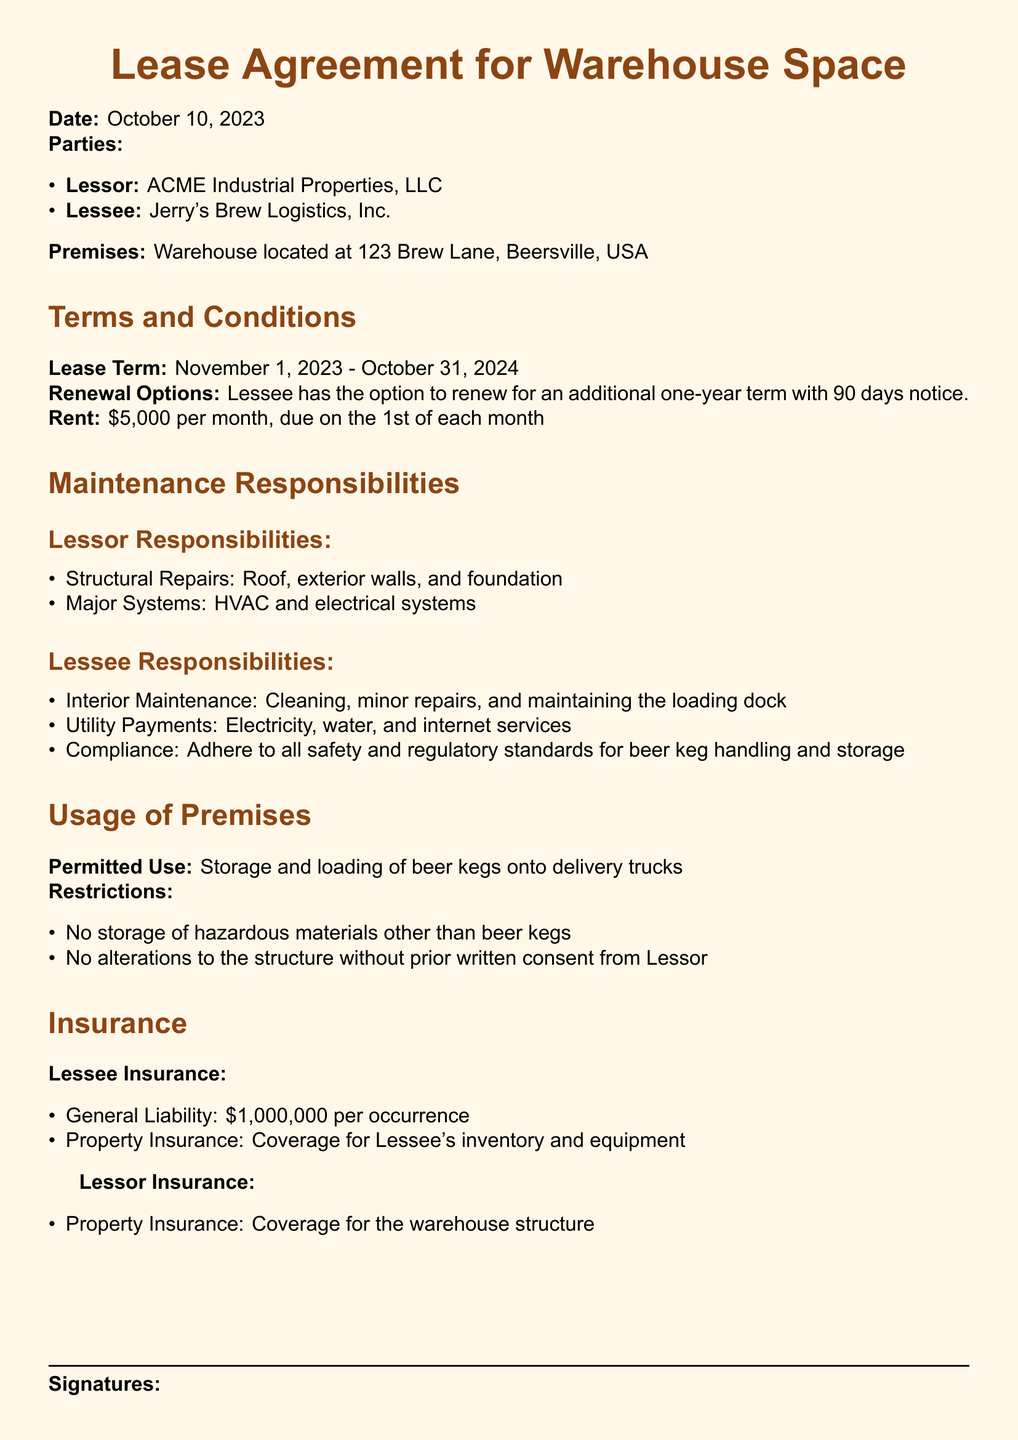What is the lease term? The lease term is specifically stated in the document as starting and ending dates from November 1, 2023 to October 31, 2024.
Answer: November 1, 2023 - October 31, 2024 Who is the lessor? The document specifies the lessor's name at the beginning of the agreement.
Answer: ACME Industrial Properties, LLC What is the monthly rent amount? The rent amount is clearly mentioned in the terms section of the document.
Answer: $5,000 What is one of the lessee's responsibilities? The document lists several responsibilities of the lessee in the maintenance section.
Answer: Interior Maintenance What is the permitted use of the premises? The permitted use is outlined in the usage section, providing clarity on how the warehouse space can be utilized.
Answer: Storage and loading of beer kegs onto delivery trucks What insurance coverage is required for the lessee? Specific insurance requirements for the lessee are detailed in the insurance section of the document.
Answer: General Liability: $1,000,000 per occurrence What is the notice period for lease renewal? The notice period for renewal is specified in the terms and conditions section of the document.
Answer: 90 days What type of repairs is the lessor responsible for? The document specifies the types of repairs the lessor is responsible for under maintenance responsibilities.
Answer: Structural Repairs 